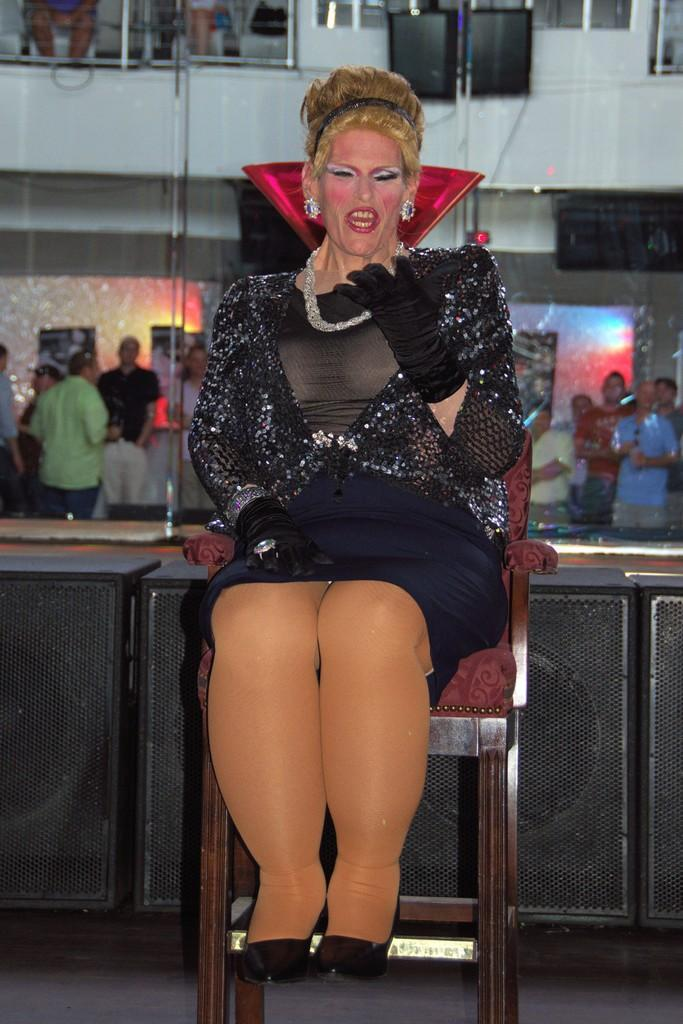Who is the main subject in the image? There is a woman in the image. What is the woman doing in the image? The woman is sitting on a chair. Can you describe the background of the image? There are people in the background of the image. What type of snake is wrapped around the woman's arm in the image? There is no snake present in the image; the woman is simply sitting on a chair. 